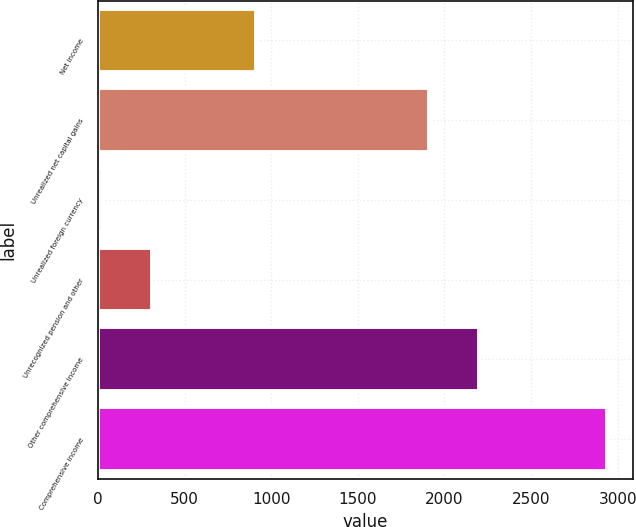Convert chart. <chart><loc_0><loc_0><loc_500><loc_500><bar_chart><fcel>Net income<fcel>Unrealized net capital gains<fcel>Unrealized foreign currency<fcel>Unrecognized pension and other<fcel>Other comprehensive income<fcel>Comprehensive income<nl><fcel>911<fcel>1911<fcel>23<fcel>314.6<fcel>2202.6<fcel>2939<nl></chart> 